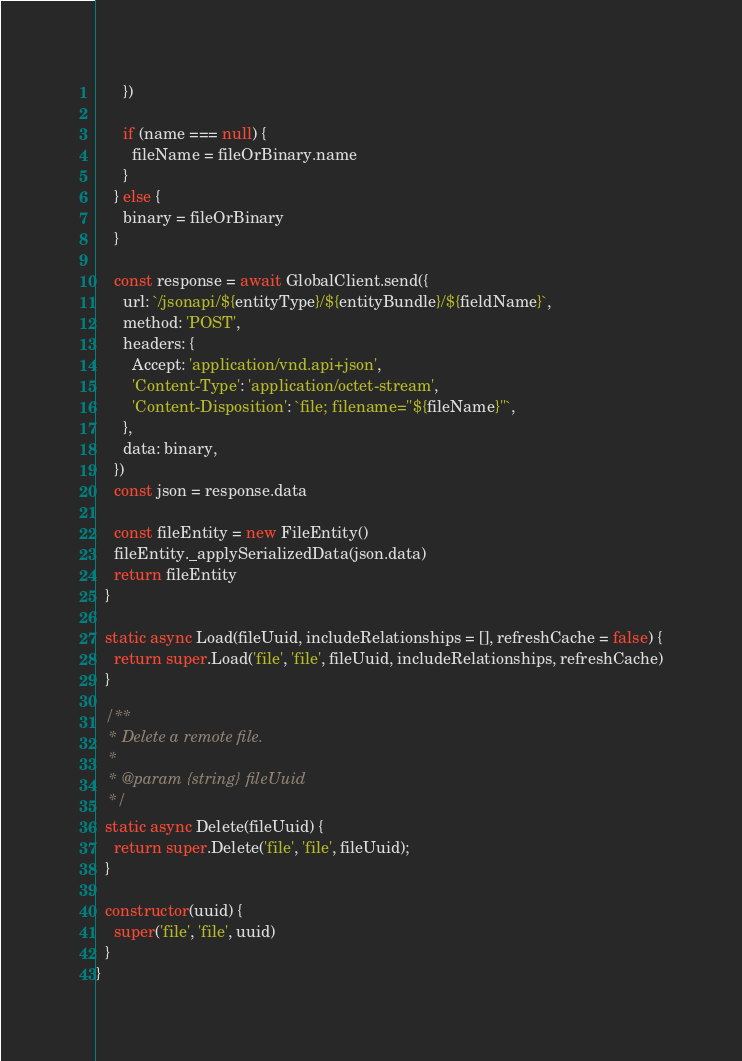Convert code to text. <code><loc_0><loc_0><loc_500><loc_500><_JavaScript_>      })

      if (name === null) {
        fileName = fileOrBinary.name
      }
    } else {
      binary = fileOrBinary
    }

    const response = await GlobalClient.send({
      url: `/jsonapi/${entityType}/${entityBundle}/${fieldName}`,
      method: 'POST',
      headers: {
        Accept: 'application/vnd.api+json',
        'Content-Type': 'application/octet-stream',
        'Content-Disposition': `file; filename="${fileName}"`,
      },
      data: binary,
    })
    const json = response.data

    const fileEntity = new FileEntity()
    fileEntity._applySerializedData(json.data)
    return fileEntity
  }

  static async Load(fileUuid, includeRelationships = [], refreshCache = false) {
    return super.Load('file', 'file', fileUuid, includeRelationships, refreshCache)
  }

  /**
   * Delete a remote file.
   *
   * @param {string} fileUuid
   */
  static async Delete(fileUuid) {
    return super.Delete('file', 'file', fileUuid);
  }

  constructor(uuid) {
    super('file', 'file', uuid)
  }
}
</code> 